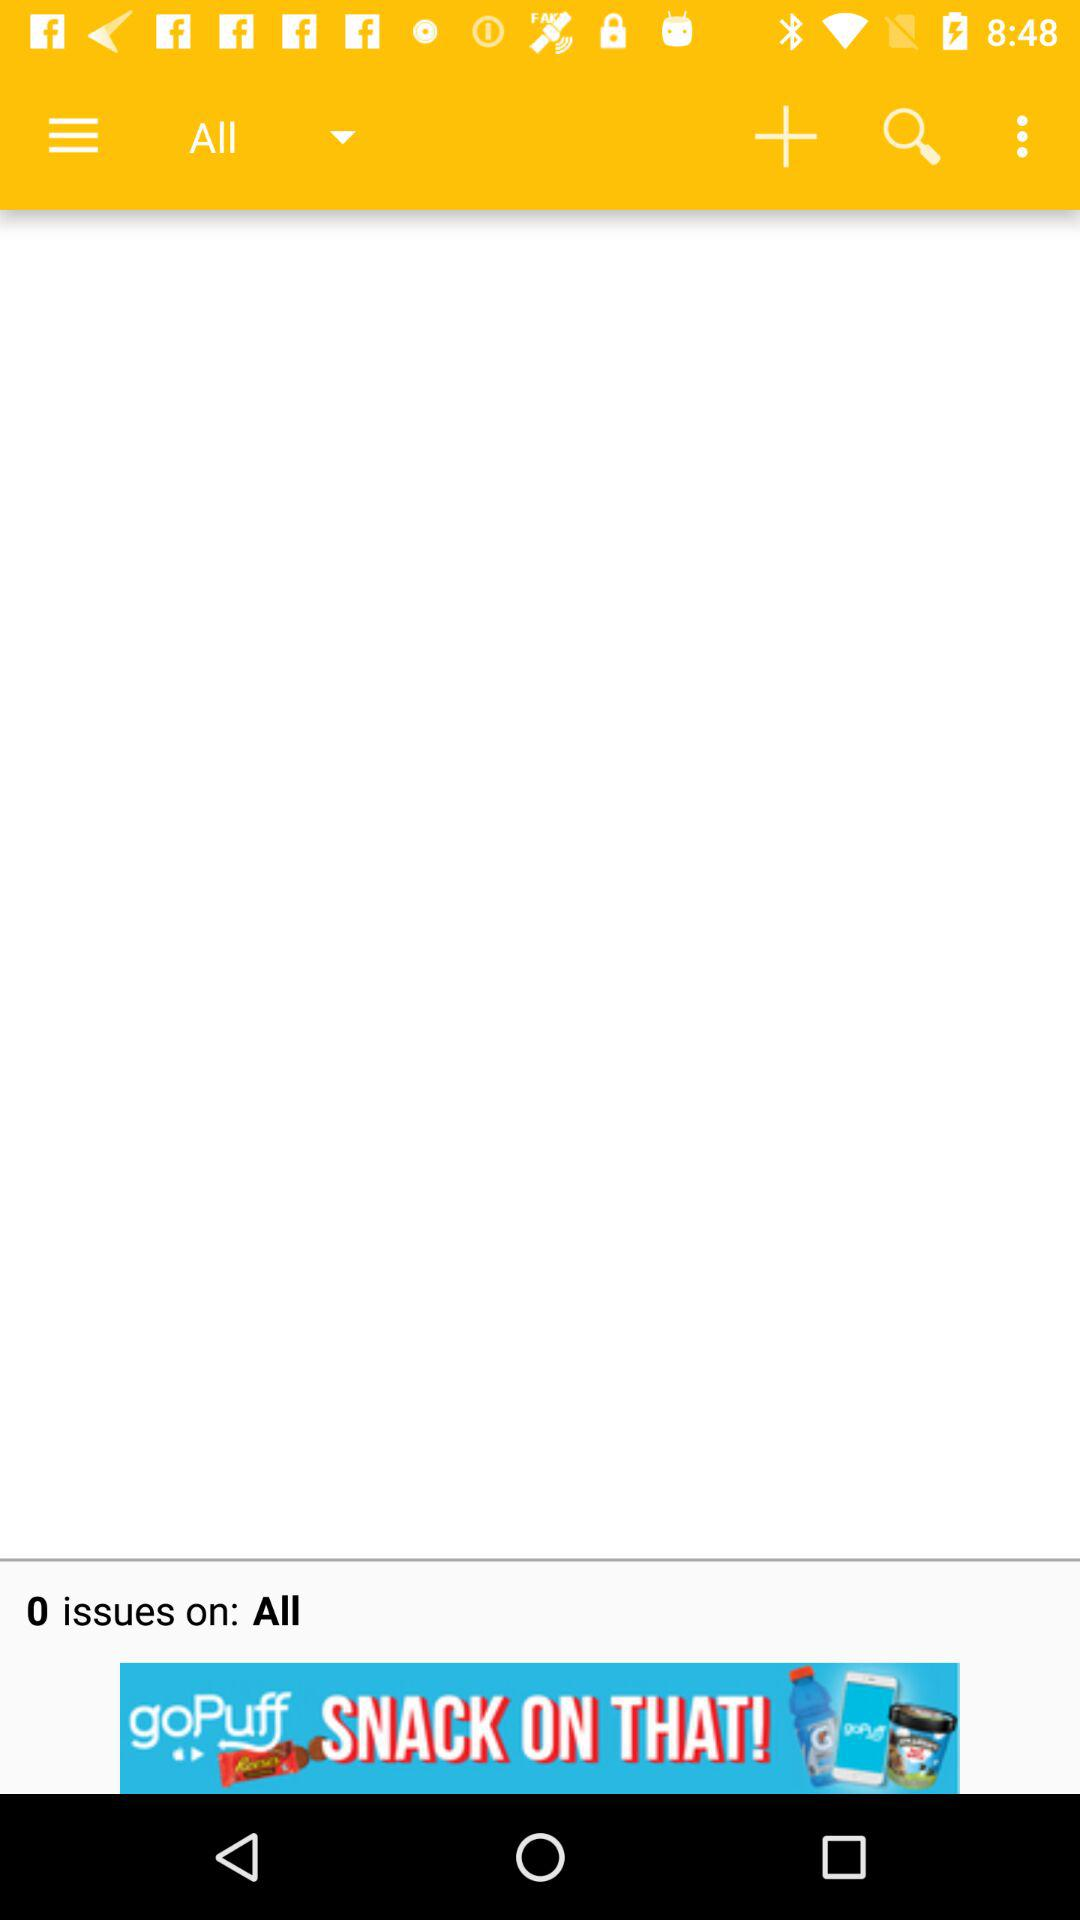What are all the options in the drop-down menu?
When the provided information is insufficient, respond with <no answer>. <no answer> 